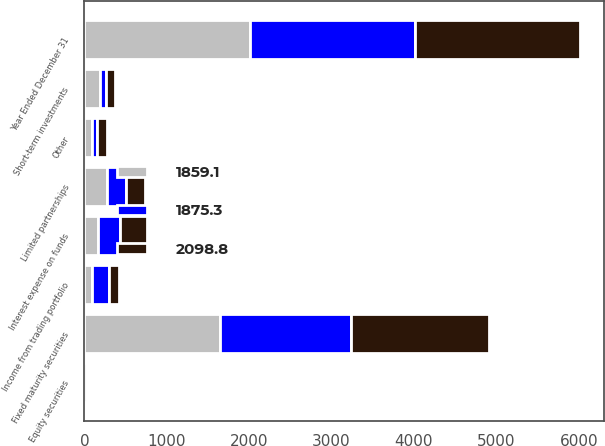<chart> <loc_0><loc_0><loc_500><loc_500><stacked_bar_chart><ecel><fcel>Year Ended December 31<fcel>Fixed maturity securities<fcel>Short-term investments<fcel>Limited partnerships<fcel>Equity securities<fcel>Income from trading portfolio<fcel>Interest expense on funds<fcel>Other<nl><fcel>1859.1<fcel>2005<fcel>1644.4<fcel>191<fcel>270.7<fcel>30.4<fcel>89.5<fcel>165.8<fcel>90.9<nl><fcel>1875.3<fcel>2004<fcel>1593.1<fcel>71.8<fcel>238.5<fcel>18.4<fcel>208.5<fcel>261.1<fcel>57.6<nl><fcel>2098.8<fcel>2003<fcel>1670.4<fcel>103.2<fcel>220.6<fcel>23.7<fcel>117.8<fcel>334.6<fcel>125.9<nl></chart> 